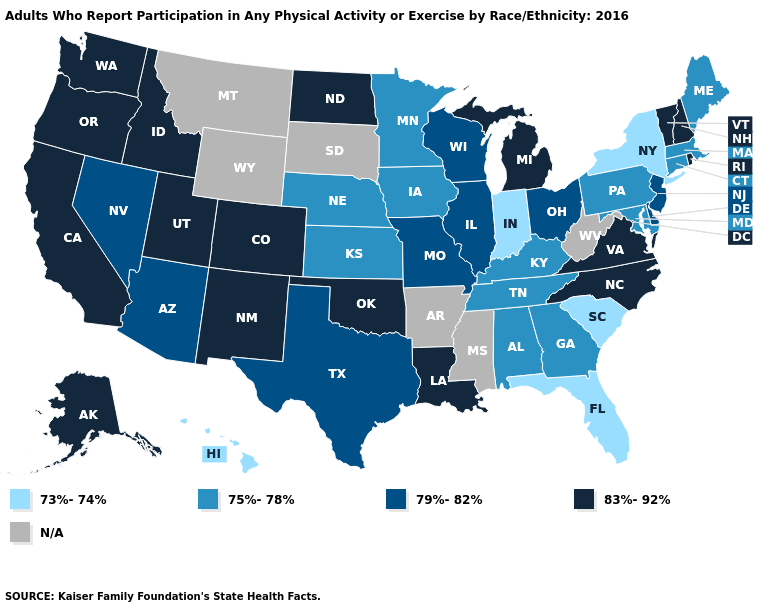Name the states that have a value in the range N/A?
Short answer required. Arkansas, Mississippi, Montana, South Dakota, West Virginia, Wyoming. Which states have the lowest value in the USA?
Short answer required. Florida, Hawaii, Indiana, New York, South Carolina. Name the states that have a value in the range 75%-78%?
Give a very brief answer. Alabama, Connecticut, Georgia, Iowa, Kansas, Kentucky, Maine, Maryland, Massachusetts, Minnesota, Nebraska, Pennsylvania, Tennessee. Which states hav the highest value in the MidWest?
Be succinct. Michigan, North Dakota. What is the highest value in the West ?
Answer briefly. 83%-92%. Does Idaho have the highest value in the USA?
Be succinct. Yes. Name the states that have a value in the range 73%-74%?
Concise answer only. Florida, Hawaii, Indiana, New York, South Carolina. Does Alabama have the lowest value in the South?
Keep it brief. No. Does the map have missing data?
Short answer required. Yes. What is the value of Georgia?
Concise answer only. 75%-78%. What is the highest value in states that border Iowa?
Short answer required. 79%-82%. Among the states that border Colorado , which have the highest value?
Quick response, please. New Mexico, Oklahoma, Utah. What is the value of Connecticut?
Give a very brief answer. 75%-78%. 